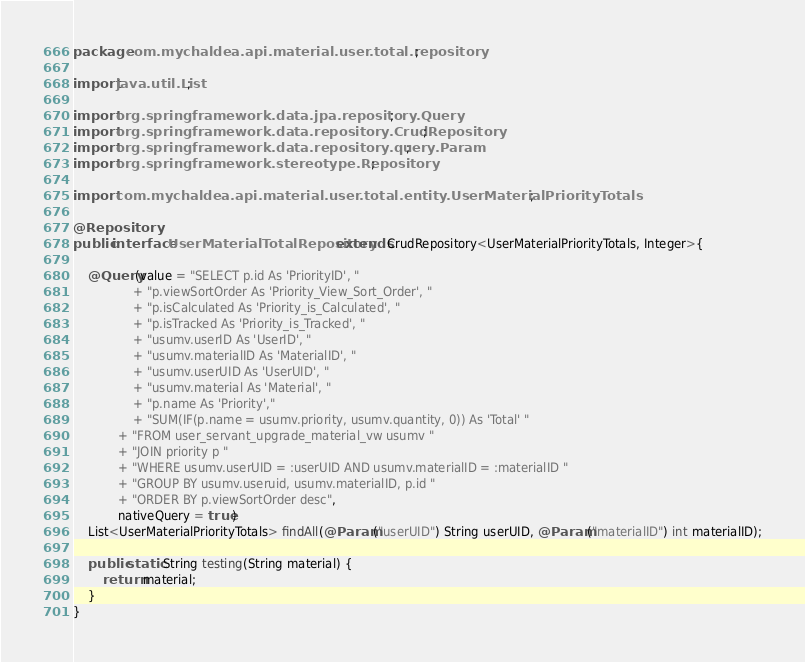Convert code to text. <code><loc_0><loc_0><loc_500><loc_500><_Java_>package com.mychaldea.api.material.user.total.repository;

import java.util.List;

import org.springframework.data.jpa.repository.Query;
import org.springframework.data.repository.CrudRepository;
import org.springframework.data.repository.query.Param;
import org.springframework.stereotype.Repository;

import com.mychaldea.api.material.user.total.entity.UserMaterialPriorityTotals;

@Repository
public interface UserMaterialTotalRepository extends CrudRepository<UserMaterialPriorityTotals, Integer>{

	@Query(value = "SELECT p.id As 'PriorityID', "
				+ "p.viewSortOrder As 'Priority_View_Sort_Order', "
				+ "p.isCalculated As 'Priority_is_Calculated', "
				+ "p.isTracked As 'Priority_is_Tracked', "
				+ "usumv.userID As 'UserID', "
				+ "usumv.materialID As 'MaterialID', "
				+ "usumv.userUID As 'UserUID', "
				+ "usumv.material As 'Material', "
				+ "p.name As 'Priority',"
				+ "SUM(IF(p.name = usumv.priority, usumv.quantity, 0)) As 'Total' "
			+ "FROM user_servant_upgrade_material_vw usumv "
			+ "JOIN priority p "
			+ "WHERE usumv.userUID = :userUID AND usumv.materialID = :materialID "
			+ "GROUP BY usumv.useruid, usumv.materialID, p.id "
			+ "ORDER BY p.viewSortOrder desc",
			nativeQuery = true)
	List<UserMaterialPriorityTotals> findAll(@Param("userUID") String userUID, @Param("materialID") int materialID);
	
	public static String testing(String material) {
		return material;
	}
}
</code> 